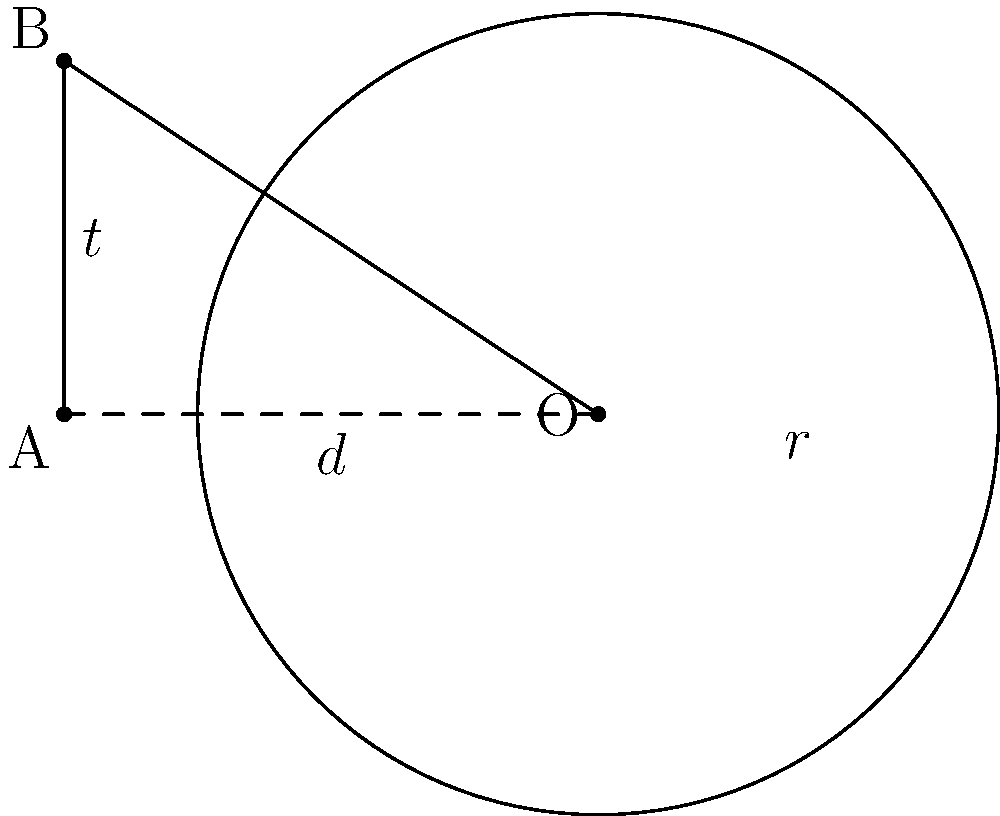In a circle with center O, a tangent line touches the circle at point B. If the length of the tangent line (AB) is 5 units and the distance from the center of the circle to point A is 8 units, what is the radius of the circle? Round your answer to two decimal places. Let's approach this step-by-step, using the Pythagorean theorem and the properties of tangent lines:

1) Let $r$ be the radius of the circle, $d$ be the distance OA, and $t$ be the length of the tangent AB.

2) We know that $d = 8$ and $t = 5$.

3) In right triangle OAB, OB is the radius and perpendicular to the tangent AB. This forms a right-angled triangle.

4) Using the Pythagorean theorem in triangle OAB:

   $r^2 + t^2 = d^2$

5) Substituting the known values:

   $r^2 + 5^2 = 8^2$

6) Simplify:

   $r^2 + 25 = 64$

7) Subtract 25 from both sides:

   $r^2 = 39$

8) Take the square root of both sides:

   $r = \sqrt{39}$

9) Calculate and round to two decimal places:

   $r \approx 6.24$

Therefore, the radius of the circle is approximately 6.24 units.
Answer: $6.24$ units 